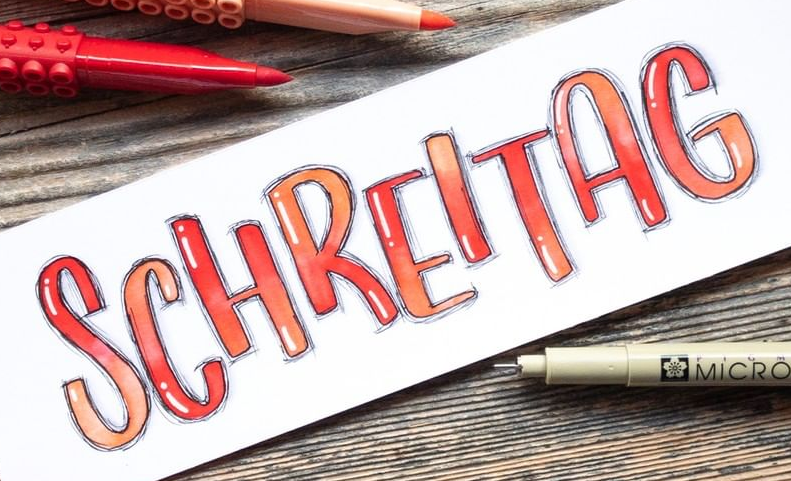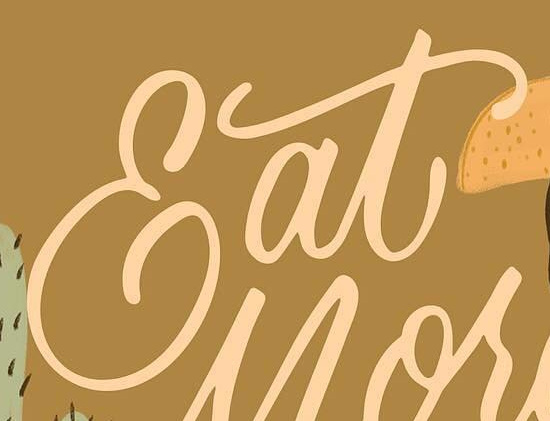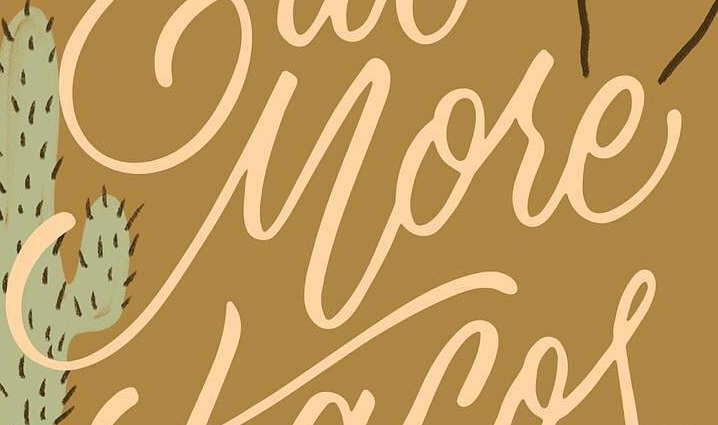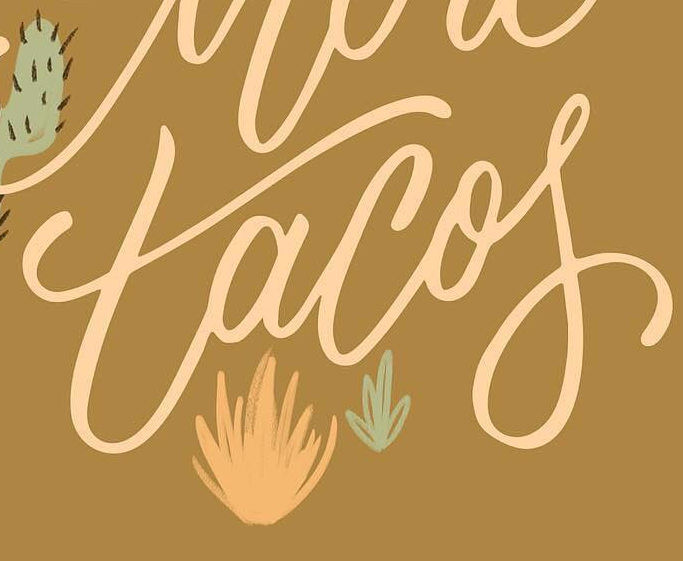What text appears in these images from left to right, separated by a semicolon? SCHREITAG; Eat; More; tacof 